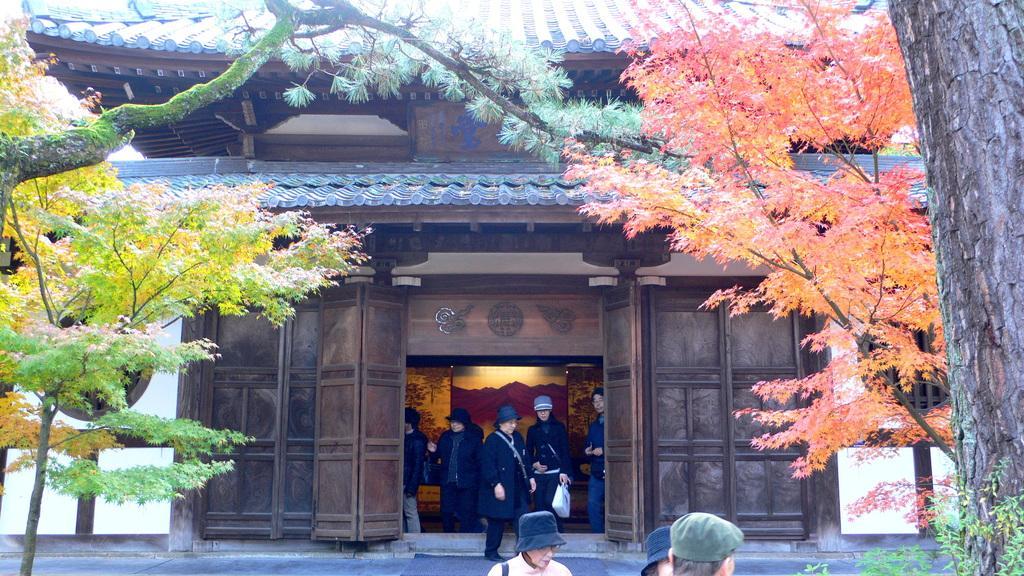Could you give a brief overview of what you see in this image? In this picture we can see some people are standing and in front of the people there are trees and behind the people there is a wooden wall and it looks like a house. 